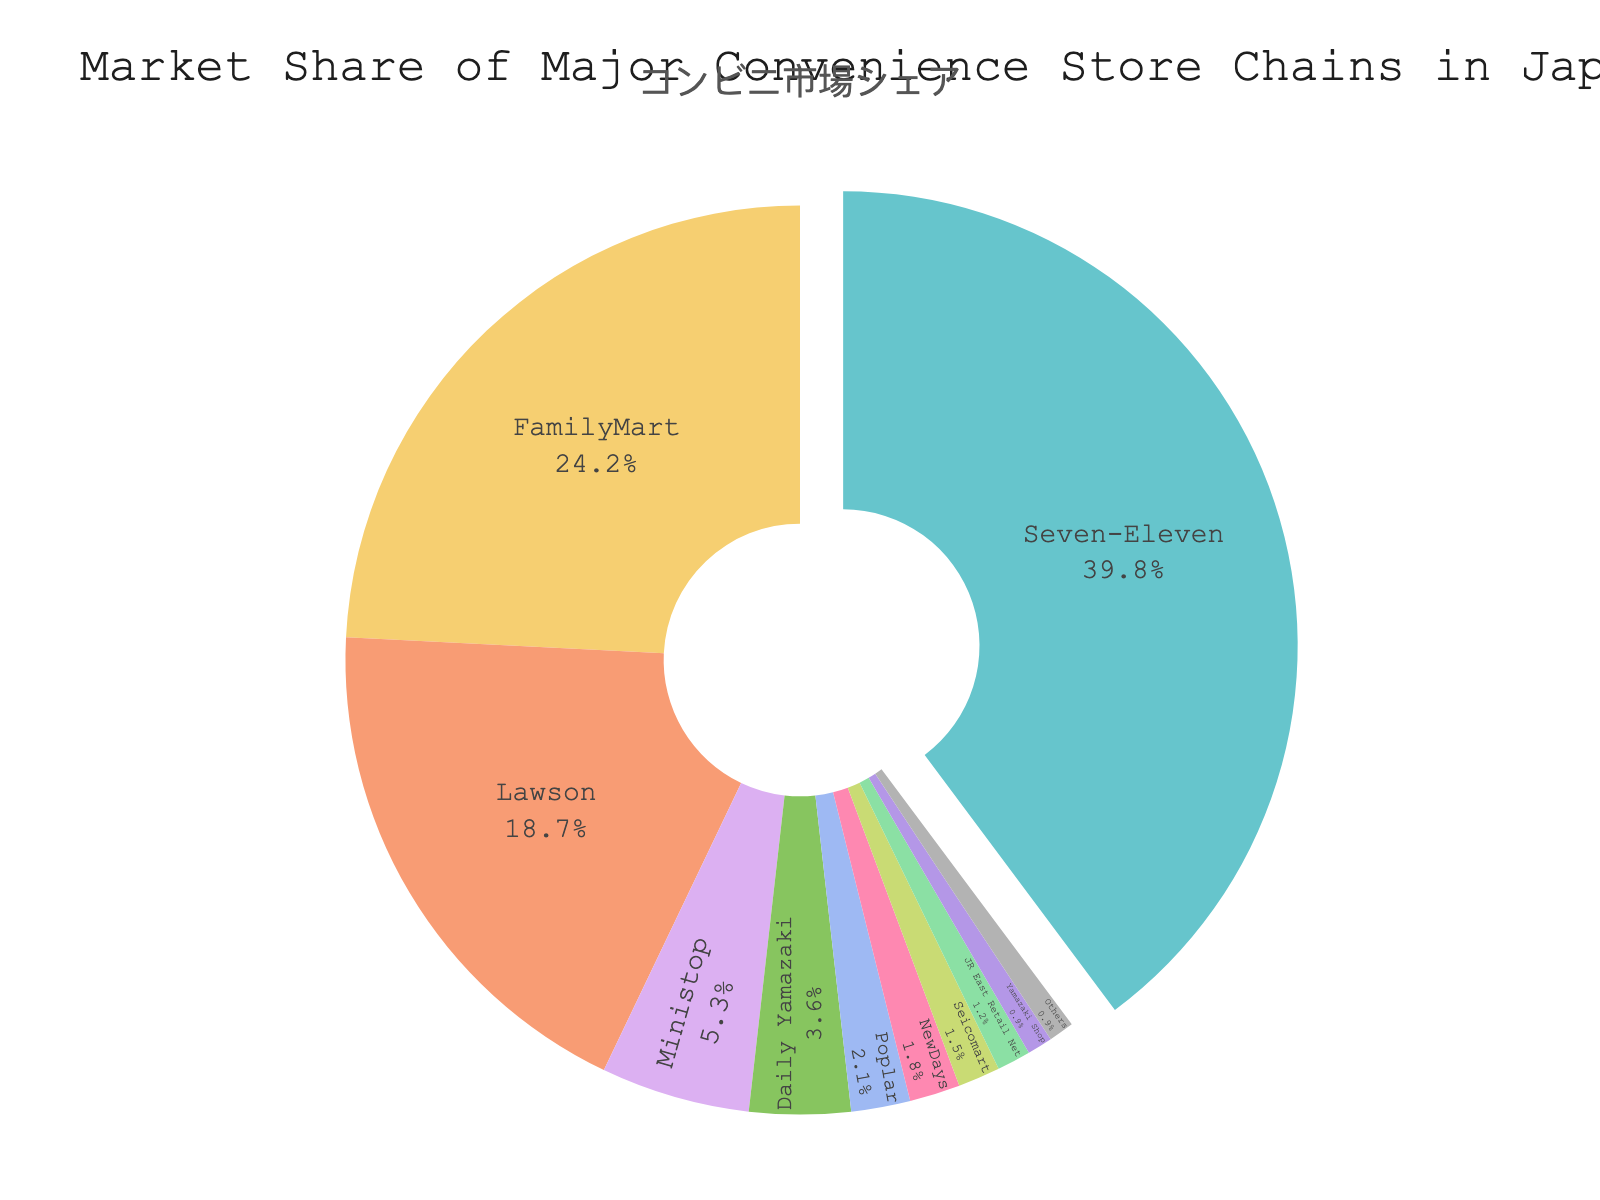What is the market share of Seven-Eleven? Seven-Eleven has the largest slice in the pie chart. According to the data, its market share is 39.8%.
Answer: 39.8% What's the combined market share of FamilyMart and Lawson? The market share of FamilyMart is 24.2%, and Lawson is 18.7%. Adding these two values gives us 24.2 + 18.7 = 42.9%.
Answer: 42.9% Which convenience store chain has the smallest market share in the chart? From the pie chart, the smallest slice is for Yamazaki Shop and Others, both with a market share of 0.9%.
Answer: Yamazaki Shop and Others Is the market share of Seven-Eleven more than the combined market share of Ministop, Daily Yamazaki, and Poplar? Add the market shares of Ministop (5.3%), Daily Yamazaki (3.6%), and Poplar (2.1%), which results in 5.3 + 3.6 + 2.1 = 11%. Since 39.8% (Seven-Eleven) is greater than 11%, the answer is yes.
Answer: Yes What percentage of the market does Seicomart hold compared to Daily Yamazaki? The market share of Seicomart is 1.5%, and Daily Yamazaki is 3.6%. Dividing Seicomart's market share by Daily Yamazaki's market share gives us 1.5 / 3.6 ≈ 0.4167, or around 41.67%.
Answer: 41.67% Which chain has a market share larger than 10% but smaller than 30%? From the chart, FamilyMart has 24.2% and Lawson has 18.7%. Both are more than 10% and less than 30%.
Answer: FamilyMart and Lawson What is the total market share of chains with less than 3% market share each? The chains with less than 3% market share are Poplar (2.1%), NewDays (1.8%), Seicomart (1.5%), JR East Retail Net (1.2%), and Yamazaki Shop (0.9%) and Others (0.9%). Summing them, 2.1 + 1.8 + 1.5 + 1.2 + 0.9 + 0.9 = 8.4%.
Answer: 8.4% Compare the market share of FamilyMart to the combined share of NewDays and Seicomart. FamilyMart holds 24.2%, and the combined share of NewDays (1.8%) and Seicomart (1.5%) is 1.8 + 1.5 = 3.3%. FamilyMart's market share is thus much larger.
Answer: FamilyMart has a much larger share What is the difference in market share between the largest and smallest chains? The largest chain, Seven-Eleven, has a market share of 39.8%. The smallest chains, Yamazaki Shop and Others, have a market share of 0.9% each. The difference is 39.8 - 0.9 = 38.9%.
Answer: 38.9% Approximately, what fraction of the market share does Lawson and Ministop combined hold? Lawson has a market share of 18.7% and Ministop has 5.3%. The combined share is 18.7 + 5.3 = 24%. This is approximately 1/4 or 25% of the market.
Answer: Approximately 1/4 or 25% 